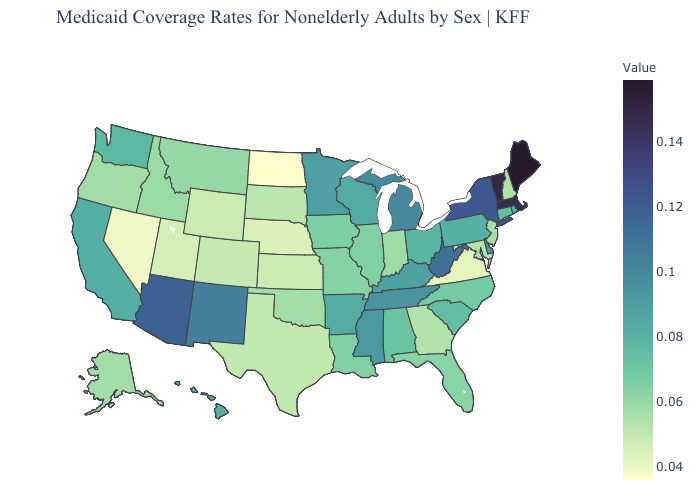Is the legend a continuous bar?
Write a very short answer. Yes. Does Connecticut have the highest value in the USA?
Give a very brief answer. No. Among the states that border North Dakota , which have the lowest value?
Quick response, please. South Dakota. Which states have the lowest value in the Northeast?
Short answer required. New Hampshire. Does North Dakota have the lowest value in the MidWest?
Be succinct. Yes. Does North Dakota have the lowest value in the USA?
Give a very brief answer. Yes. Is the legend a continuous bar?
Give a very brief answer. Yes. Does Louisiana have a higher value than West Virginia?
Quick response, please. No. Among the states that border New Hampshire , does Vermont have the highest value?
Keep it brief. No. 